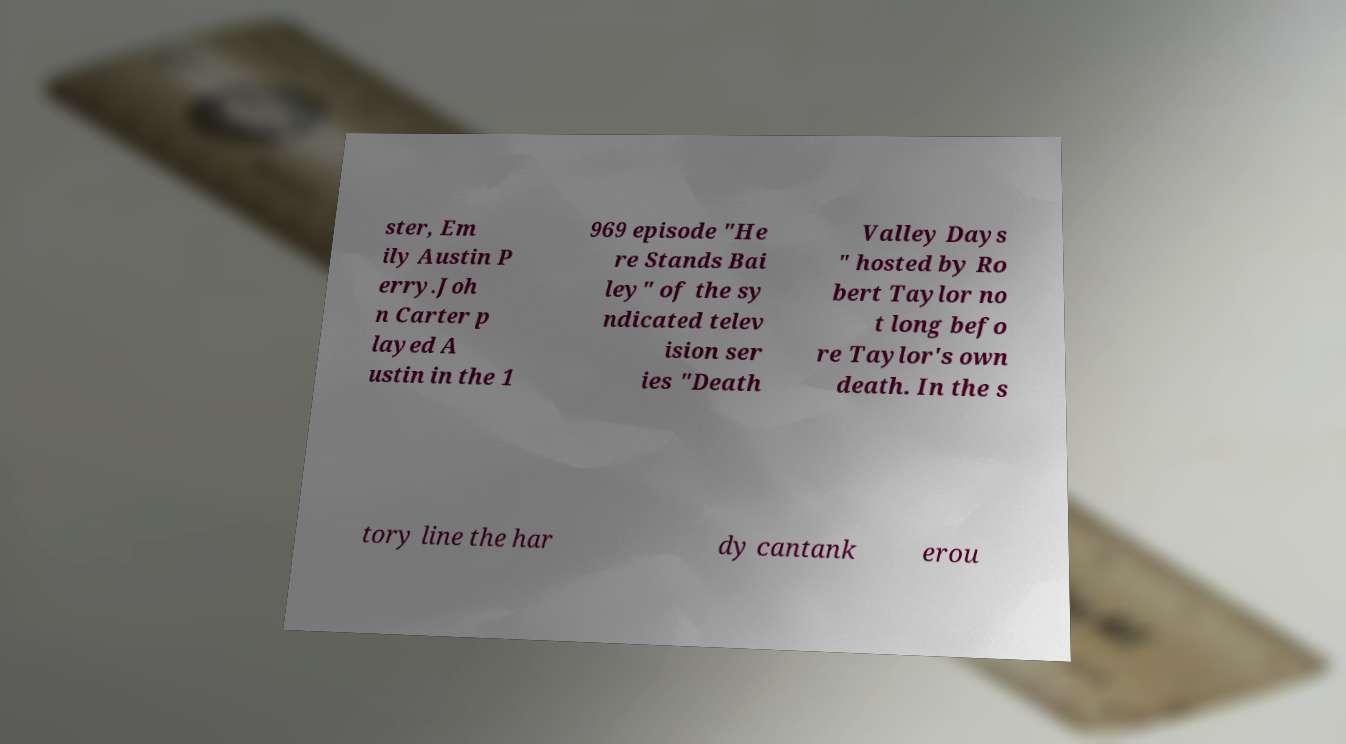For documentation purposes, I need the text within this image transcribed. Could you provide that? ster, Em ily Austin P erry.Joh n Carter p layed A ustin in the 1 969 episode "He re Stands Bai ley" of the sy ndicated telev ision ser ies "Death Valley Days " hosted by Ro bert Taylor no t long befo re Taylor's own death. In the s tory line the har dy cantank erou 